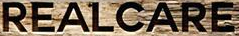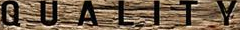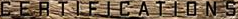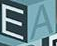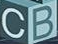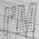What words can you see in these images in sequence, separated by a semicolon? REALCARE; QUALITY; CERTIFICATIONS; EA; CB; I'M 